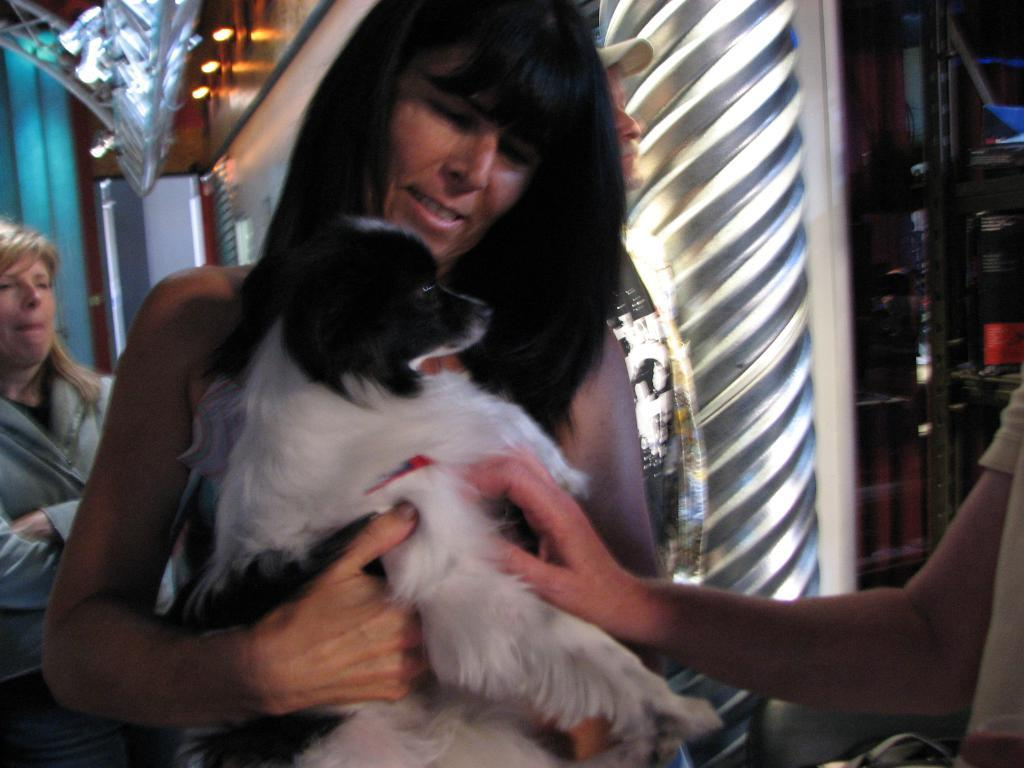What is the woman in the image holding? The woman is holding a dog in the image. How many people are present in the image? There are three people in the image: a woman holding a dog, another woman, and a man wearing a cap. Can you describe the man's attire in the image? The man is wearing a cap in the image. What can be seen in the background of the image? There is a light visible in the background of the image. What type of goose is sitting in the jail cell in the image? There is no jail cell or goose present in the image. Is there a glove visible on any of the people in the image? There is no glove visible on any of the people in the image. 